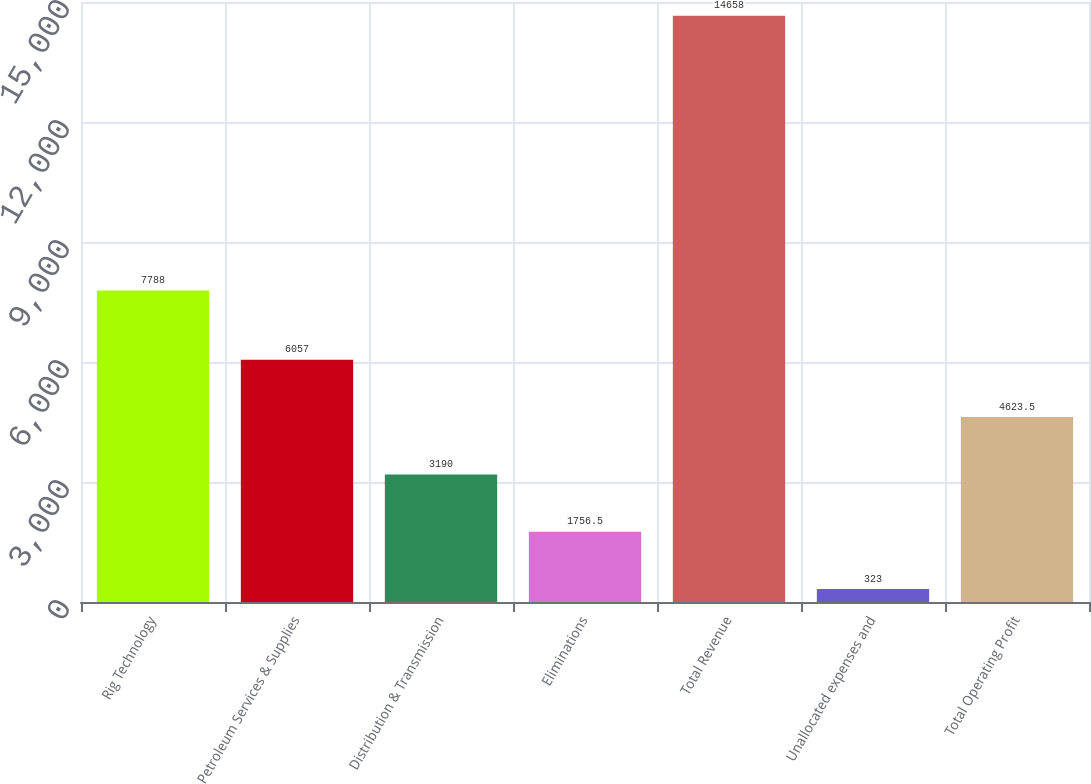Convert chart to OTSL. <chart><loc_0><loc_0><loc_500><loc_500><bar_chart><fcel>Rig Technology<fcel>Petroleum Services & Supplies<fcel>Distribution & Transmission<fcel>Eliminations<fcel>Total Revenue<fcel>Unallocated expenses and<fcel>Total Operating Profit<nl><fcel>7788<fcel>6057<fcel>3190<fcel>1756.5<fcel>14658<fcel>323<fcel>4623.5<nl></chart> 